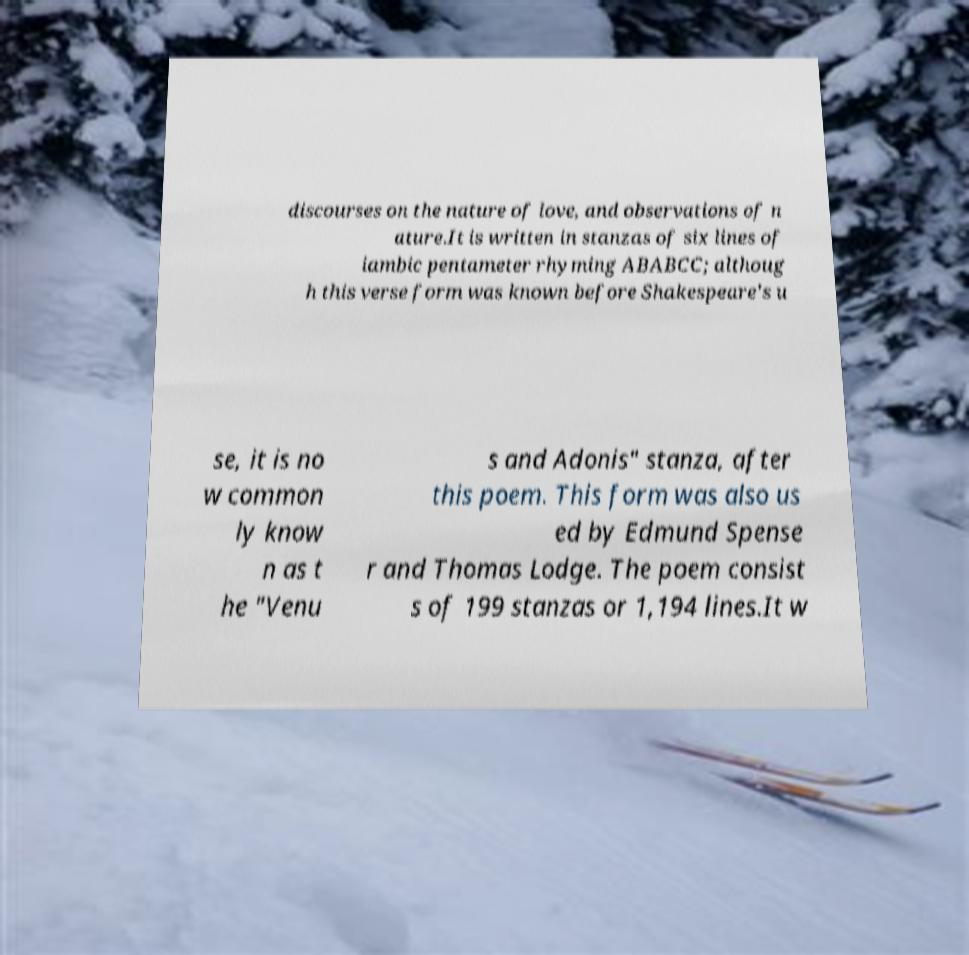Please read and relay the text visible in this image. What does it say? discourses on the nature of love, and observations of n ature.It is written in stanzas of six lines of iambic pentameter rhyming ABABCC; althoug h this verse form was known before Shakespeare's u se, it is no w common ly know n as t he "Venu s and Adonis" stanza, after this poem. This form was also us ed by Edmund Spense r and Thomas Lodge. The poem consist s of 199 stanzas or 1,194 lines.It w 